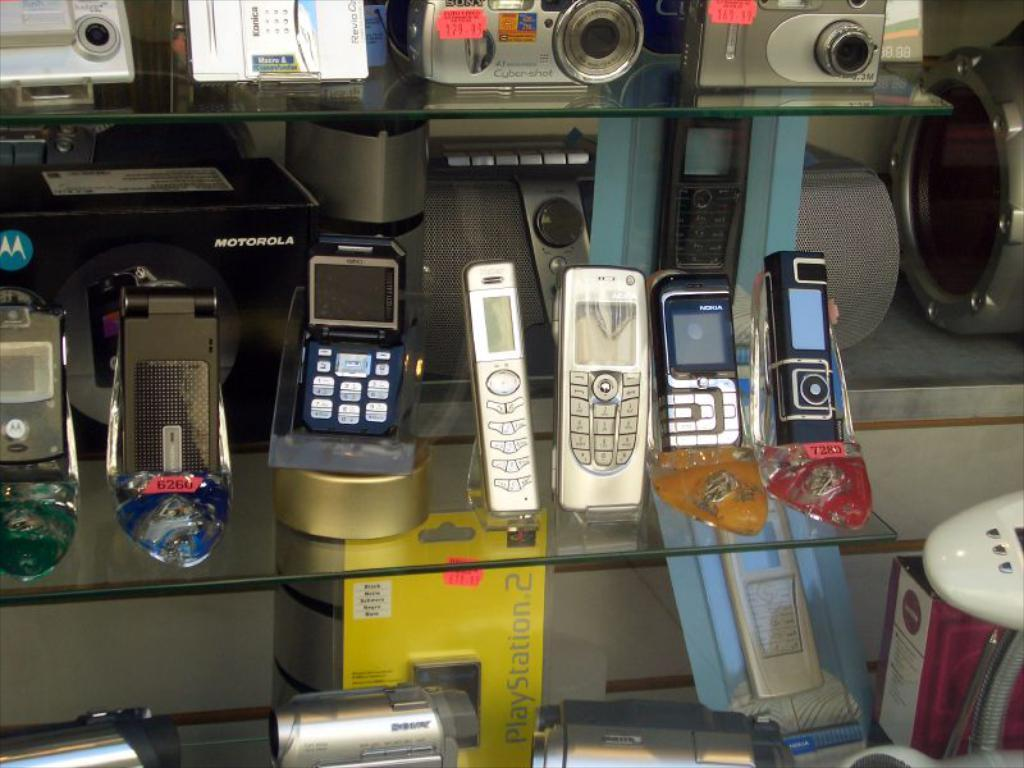<image>
Provide a brief description of the given image. A Playstation 2 memory card sits on a shelf underneath some phones. 